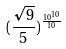Convert formula to latex. <formula><loc_0><loc_0><loc_500><loc_500>( \frac { \sqrt { 9 } } { 5 } ) ^ { \frac { 1 0 ^ { 1 0 } } { 1 0 } }</formula> 